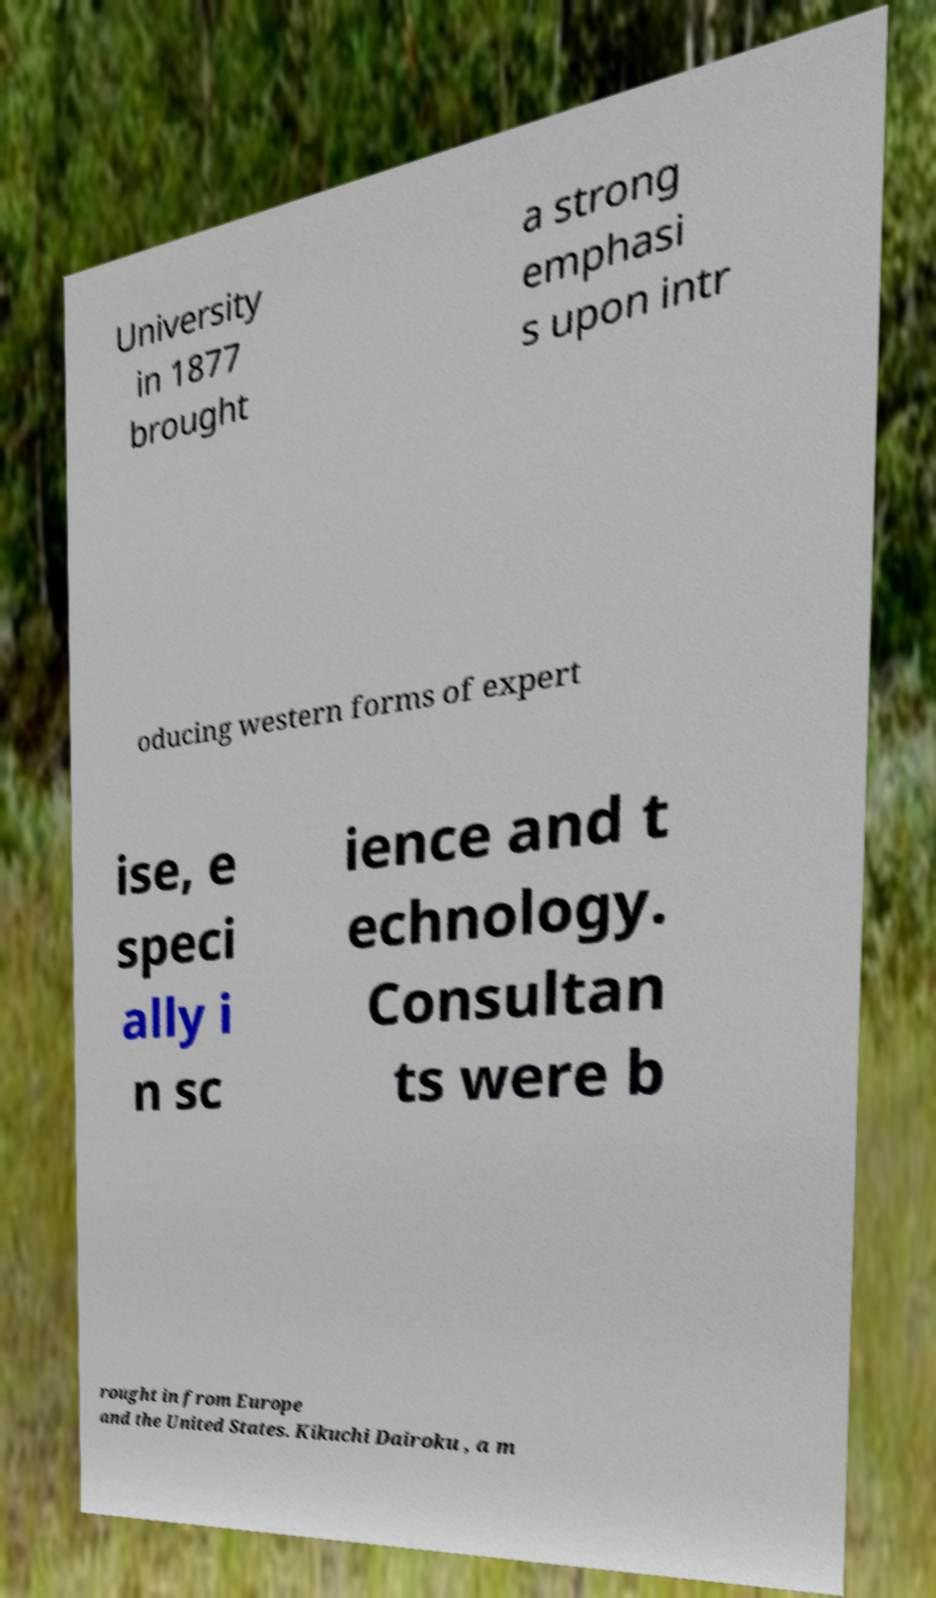Please identify and transcribe the text found in this image. University in 1877 brought a strong emphasi s upon intr oducing western forms of expert ise, e speci ally i n sc ience and t echnology. Consultan ts were b rought in from Europe and the United States. Kikuchi Dairoku , a m 